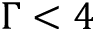<formula> <loc_0><loc_0><loc_500><loc_500>\Gamma < 4</formula> 